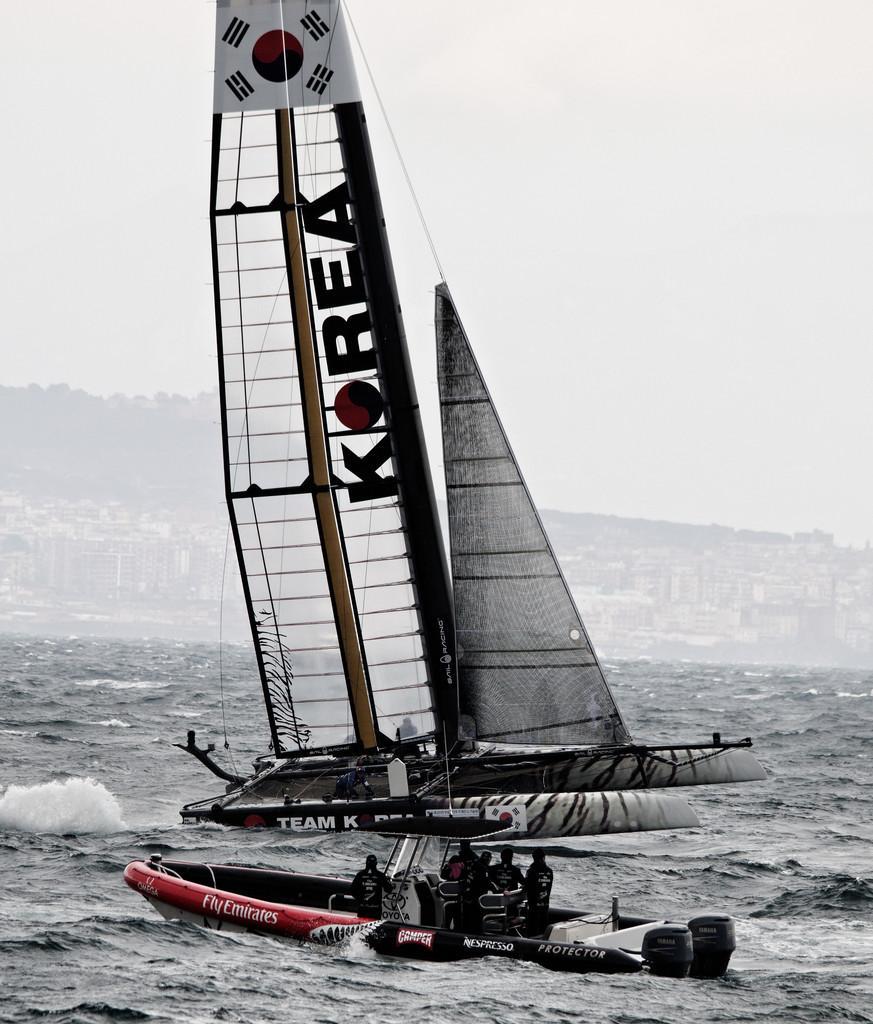Please provide a concise description of this image. In this image, we can see few people are sailing boats on the water. Background we can see buildings, trees and sky. 